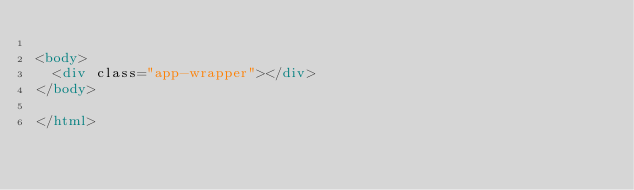Convert code to text. <code><loc_0><loc_0><loc_500><loc_500><_HTML_>
<body>
  <div class="app-wrapper"></div>
</body>

</html></code> 